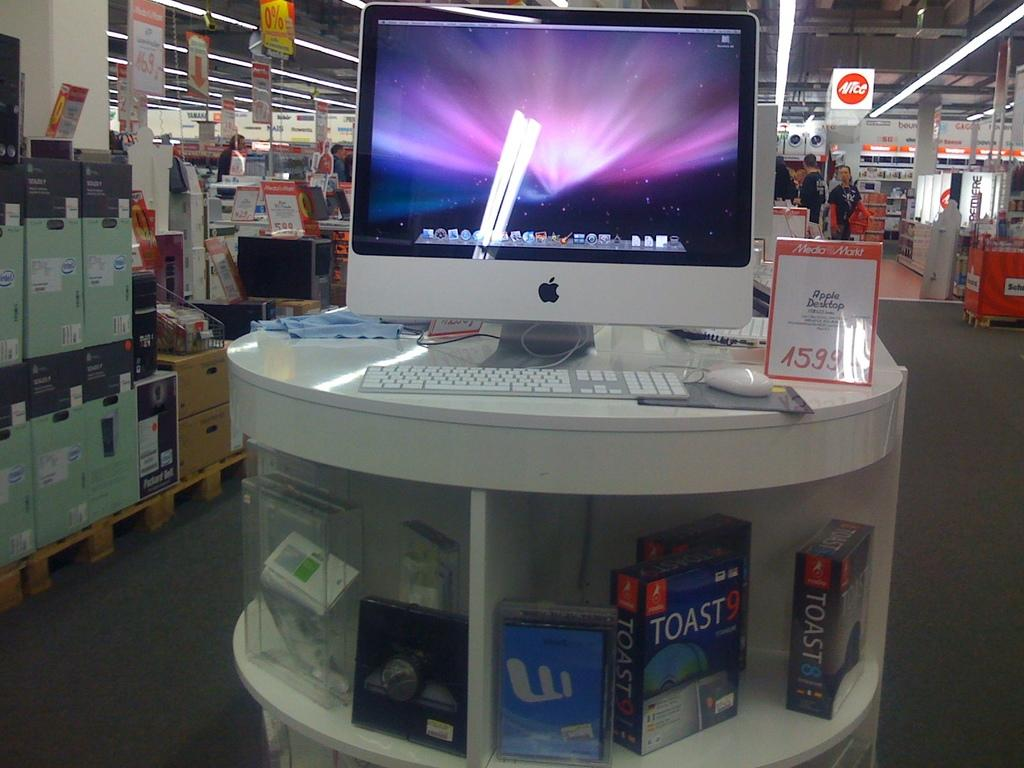<image>
Render a clear and concise summary of the photo. Display of a silver Apple computer with a Toast9 box below 